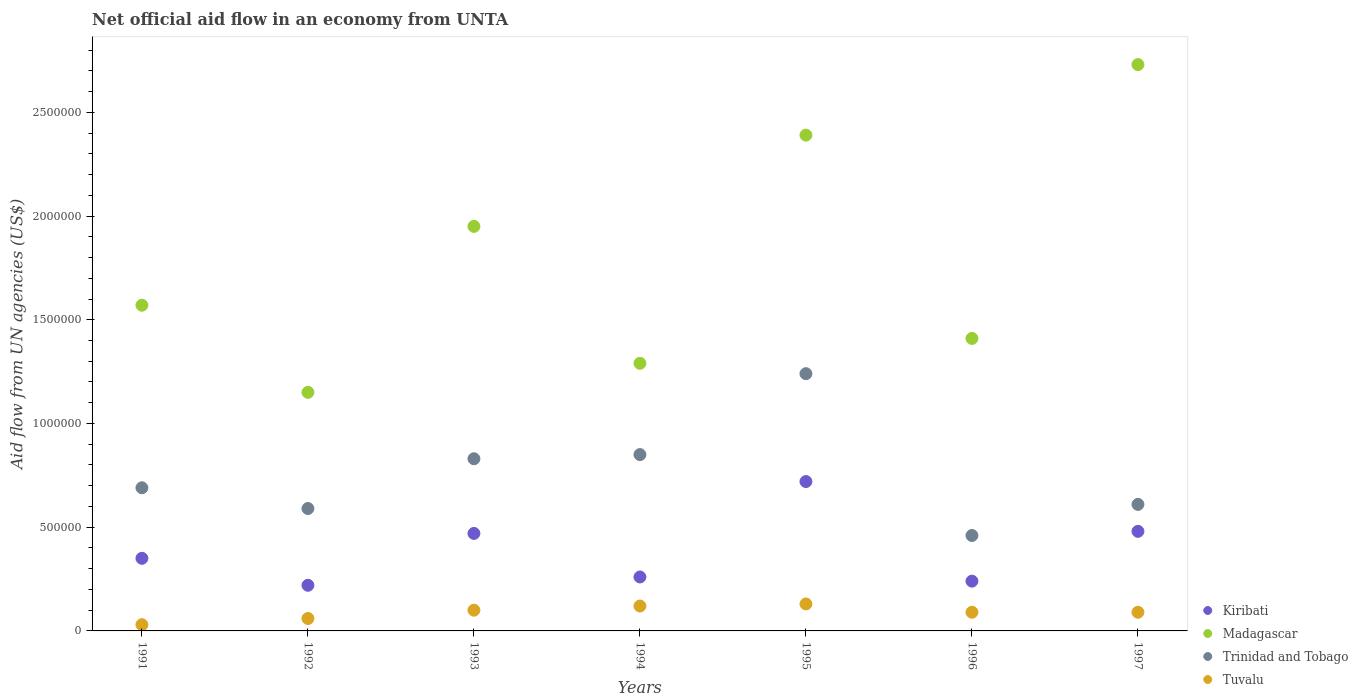What is the net official aid flow in Trinidad and Tobago in 1992?
Provide a succinct answer. 5.90e+05. Across all years, what is the maximum net official aid flow in Tuvalu?
Your answer should be very brief. 1.30e+05. Across all years, what is the minimum net official aid flow in Madagascar?
Give a very brief answer. 1.15e+06. In which year was the net official aid flow in Trinidad and Tobago maximum?
Offer a very short reply. 1995. In which year was the net official aid flow in Madagascar minimum?
Your response must be concise. 1992. What is the total net official aid flow in Tuvalu in the graph?
Give a very brief answer. 6.20e+05. What is the difference between the net official aid flow in Trinidad and Tobago in 1993 and the net official aid flow in Tuvalu in 1996?
Ensure brevity in your answer.  7.40e+05. What is the average net official aid flow in Madagascar per year?
Your response must be concise. 1.78e+06. In the year 1991, what is the difference between the net official aid flow in Kiribati and net official aid flow in Madagascar?
Offer a terse response. -1.22e+06. What is the ratio of the net official aid flow in Madagascar in 1993 to that in 1994?
Your answer should be very brief. 1.51. What is the difference between the highest and the lowest net official aid flow in Trinidad and Tobago?
Your answer should be compact. 7.80e+05. Is it the case that in every year, the sum of the net official aid flow in Trinidad and Tobago and net official aid flow in Tuvalu  is greater than the net official aid flow in Madagascar?
Offer a terse response. No. Does the net official aid flow in Tuvalu monotonically increase over the years?
Your answer should be very brief. No. Is the net official aid flow in Trinidad and Tobago strictly less than the net official aid flow in Kiribati over the years?
Provide a short and direct response. No. How many dotlines are there?
Your answer should be very brief. 4. Are the values on the major ticks of Y-axis written in scientific E-notation?
Provide a short and direct response. No. Does the graph contain any zero values?
Provide a succinct answer. No. Where does the legend appear in the graph?
Make the answer very short. Bottom right. How are the legend labels stacked?
Keep it short and to the point. Vertical. What is the title of the graph?
Make the answer very short. Net official aid flow in an economy from UNTA. What is the label or title of the Y-axis?
Offer a very short reply. Aid flow from UN agencies (US$). What is the Aid flow from UN agencies (US$) in Madagascar in 1991?
Ensure brevity in your answer.  1.57e+06. What is the Aid flow from UN agencies (US$) of Trinidad and Tobago in 1991?
Provide a succinct answer. 6.90e+05. What is the Aid flow from UN agencies (US$) in Madagascar in 1992?
Provide a short and direct response. 1.15e+06. What is the Aid flow from UN agencies (US$) in Trinidad and Tobago in 1992?
Ensure brevity in your answer.  5.90e+05. What is the Aid flow from UN agencies (US$) in Madagascar in 1993?
Keep it short and to the point. 1.95e+06. What is the Aid flow from UN agencies (US$) in Trinidad and Tobago in 1993?
Your response must be concise. 8.30e+05. What is the Aid flow from UN agencies (US$) in Madagascar in 1994?
Your answer should be very brief. 1.29e+06. What is the Aid flow from UN agencies (US$) of Trinidad and Tobago in 1994?
Your answer should be compact. 8.50e+05. What is the Aid flow from UN agencies (US$) in Kiribati in 1995?
Your answer should be compact. 7.20e+05. What is the Aid flow from UN agencies (US$) in Madagascar in 1995?
Offer a very short reply. 2.39e+06. What is the Aid flow from UN agencies (US$) of Trinidad and Tobago in 1995?
Provide a short and direct response. 1.24e+06. What is the Aid flow from UN agencies (US$) of Kiribati in 1996?
Your response must be concise. 2.40e+05. What is the Aid flow from UN agencies (US$) in Madagascar in 1996?
Your answer should be very brief. 1.41e+06. What is the Aid flow from UN agencies (US$) in Kiribati in 1997?
Keep it short and to the point. 4.80e+05. What is the Aid flow from UN agencies (US$) in Madagascar in 1997?
Give a very brief answer. 2.73e+06. What is the Aid flow from UN agencies (US$) in Tuvalu in 1997?
Keep it short and to the point. 9.00e+04. Across all years, what is the maximum Aid flow from UN agencies (US$) in Kiribati?
Provide a short and direct response. 7.20e+05. Across all years, what is the maximum Aid flow from UN agencies (US$) in Madagascar?
Offer a very short reply. 2.73e+06. Across all years, what is the maximum Aid flow from UN agencies (US$) of Trinidad and Tobago?
Make the answer very short. 1.24e+06. Across all years, what is the maximum Aid flow from UN agencies (US$) in Tuvalu?
Your answer should be very brief. 1.30e+05. Across all years, what is the minimum Aid flow from UN agencies (US$) of Madagascar?
Your answer should be very brief. 1.15e+06. What is the total Aid flow from UN agencies (US$) in Kiribati in the graph?
Offer a very short reply. 2.74e+06. What is the total Aid flow from UN agencies (US$) of Madagascar in the graph?
Your answer should be compact. 1.25e+07. What is the total Aid flow from UN agencies (US$) of Trinidad and Tobago in the graph?
Make the answer very short. 5.27e+06. What is the total Aid flow from UN agencies (US$) in Tuvalu in the graph?
Ensure brevity in your answer.  6.20e+05. What is the difference between the Aid flow from UN agencies (US$) of Kiribati in 1991 and that in 1992?
Your answer should be compact. 1.30e+05. What is the difference between the Aid flow from UN agencies (US$) of Trinidad and Tobago in 1991 and that in 1992?
Provide a short and direct response. 1.00e+05. What is the difference between the Aid flow from UN agencies (US$) of Madagascar in 1991 and that in 1993?
Your answer should be very brief. -3.80e+05. What is the difference between the Aid flow from UN agencies (US$) of Trinidad and Tobago in 1991 and that in 1993?
Keep it short and to the point. -1.40e+05. What is the difference between the Aid flow from UN agencies (US$) in Tuvalu in 1991 and that in 1993?
Ensure brevity in your answer.  -7.00e+04. What is the difference between the Aid flow from UN agencies (US$) in Madagascar in 1991 and that in 1994?
Provide a succinct answer. 2.80e+05. What is the difference between the Aid flow from UN agencies (US$) of Trinidad and Tobago in 1991 and that in 1994?
Make the answer very short. -1.60e+05. What is the difference between the Aid flow from UN agencies (US$) in Tuvalu in 1991 and that in 1994?
Offer a very short reply. -9.00e+04. What is the difference between the Aid flow from UN agencies (US$) of Kiribati in 1991 and that in 1995?
Offer a terse response. -3.70e+05. What is the difference between the Aid flow from UN agencies (US$) in Madagascar in 1991 and that in 1995?
Your answer should be compact. -8.20e+05. What is the difference between the Aid flow from UN agencies (US$) in Trinidad and Tobago in 1991 and that in 1995?
Ensure brevity in your answer.  -5.50e+05. What is the difference between the Aid flow from UN agencies (US$) of Madagascar in 1991 and that in 1997?
Your answer should be very brief. -1.16e+06. What is the difference between the Aid flow from UN agencies (US$) in Trinidad and Tobago in 1991 and that in 1997?
Your answer should be very brief. 8.00e+04. What is the difference between the Aid flow from UN agencies (US$) in Kiribati in 1992 and that in 1993?
Provide a short and direct response. -2.50e+05. What is the difference between the Aid flow from UN agencies (US$) in Madagascar in 1992 and that in 1993?
Ensure brevity in your answer.  -8.00e+05. What is the difference between the Aid flow from UN agencies (US$) of Kiribati in 1992 and that in 1994?
Offer a terse response. -4.00e+04. What is the difference between the Aid flow from UN agencies (US$) of Kiribati in 1992 and that in 1995?
Keep it short and to the point. -5.00e+05. What is the difference between the Aid flow from UN agencies (US$) of Madagascar in 1992 and that in 1995?
Offer a terse response. -1.24e+06. What is the difference between the Aid flow from UN agencies (US$) of Trinidad and Tobago in 1992 and that in 1995?
Your response must be concise. -6.50e+05. What is the difference between the Aid flow from UN agencies (US$) in Madagascar in 1992 and that in 1997?
Your answer should be very brief. -1.58e+06. What is the difference between the Aid flow from UN agencies (US$) of Trinidad and Tobago in 1992 and that in 1997?
Provide a succinct answer. -2.00e+04. What is the difference between the Aid flow from UN agencies (US$) of Tuvalu in 1992 and that in 1997?
Provide a succinct answer. -3.00e+04. What is the difference between the Aid flow from UN agencies (US$) in Madagascar in 1993 and that in 1994?
Your response must be concise. 6.60e+05. What is the difference between the Aid flow from UN agencies (US$) in Trinidad and Tobago in 1993 and that in 1994?
Keep it short and to the point. -2.00e+04. What is the difference between the Aid flow from UN agencies (US$) of Kiribati in 1993 and that in 1995?
Provide a short and direct response. -2.50e+05. What is the difference between the Aid flow from UN agencies (US$) in Madagascar in 1993 and that in 1995?
Your answer should be very brief. -4.40e+05. What is the difference between the Aid flow from UN agencies (US$) in Trinidad and Tobago in 1993 and that in 1995?
Offer a terse response. -4.10e+05. What is the difference between the Aid flow from UN agencies (US$) of Tuvalu in 1993 and that in 1995?
Make the answer very short. -3.00e+04. What is the difference between the Aid flow from UN agencies (US$) of Madagascar in 1993 and that in 1996?
Offer a very short reply. 5.40e+05. What is the difference between the Aid flow from UN agencies (US$) of Kiribati in 1993 and that in 1997?
Your response must be concise. -10000. What is the difference between the Aid flow from UN agencies (US$) of Madagascar in 1993 and that in 1997?
Make the answer very short. -7.80e+05. What is the difference between the Aid flow from UN agencies (US$) of Tuvalu in 1993 and that in 1997?
Your answer should be compact. 10000. What is the difference between the Aid flow from UN agencies (US$) in Kiribati in 1994 and that in 1995?
Offer a terse response. -4.60e+05. What is the difference between the Aid flow from UN agencies (US$) in Madagascar in 1994 and that in 1995?
Your answer should be compact. -1.10e+06. What is the difference between the Aid flow from UN agencies (US$) of Trinidad and Tobago in 1994 and that in 1995?
Make the answer very short. -3.90e+05. What is the difference between the Aid flow from UN agencies (US$) of Tuvalu in 1994 and that in 1995?
Make the answer very short. -10000. What is the difference between the Aid flow from UN agencies (US$) in Madagascar in 1994 and that in 1997?
Your answer should be very brief. -1.44e+06. What is the difference between the Aid flow from UN agencies (US$) of Trinidad and Tobago in 1994 and that in 1997?
Your response must be concise. 2.40e+05. What is the difference between the Aid flow from UN agencies (US$) of Madagascar in 1995 and that in 1996?
Your answer should be very brief. 9.80e+05. What is the difference between the Aid flow from UN agencies (US$) of Trinidad and Tobago in 1995 and that in 1996?
Keep it short and to the point. 7.80e+05. What is the difference between the Aid flow from UN agencies (US$) in Madagascar in 1995 and that in 1997?
Provide a short and direct response. -3.40e+05. What is the difference between the Aid flow from UN agencies (US$) in Trinidad and Tobago in 1995 and that in 1997?
Provide a succinct answer. 6.30e+05. What is the difference between the Aid flow from UN agencies (US$) in Tuvalu in 1995 and that in 1997?
Provide a succinct answer. 4.00e+04. What is the difference between the Aid flow from UN agencies (US$) of Kiribati in 1996 and that in 1997?
Ensure brevity in your answer.  -2.40e+05. What is the difference between the Aid flow from UN agencies (US$) of Madagascar in 1996 and that in 1997?
Keep it short and to the point. -1.32e+06. What is the difference between the Aid flow from UN agencies (US$) in Trinidad and Tobago in 1996 and that in 1997?
Offer a terse response. -1.50e+05. What is the difference between the Aid flow from UN agencies (US$) in Kiribati in 1991 and the Aid flow from UN agencies (US$) in Madagascar in 1992?
Make the answer very short. -8.00e+05. What is the difference between the Aid flow from UN agencies (US$) of Kiribati in 1991 and the Aid flow from UN agencies (US$) of Trinidad and Tobago in 1992?
Provide a succinct answer. -2.40e+05. What is the difference between the Aid flow from UN agencies (US$) of Madagascar in 1991 and the Aid flow from UN agencies (US$) of Trinidad and Tobago in 1992?
Keep it short and to the point. 9.80e+05. What is the difference between the Aid flow from UN agencies (US$) of Madagascar in 1991 and the Aid flow from UN agencies (US$) of Tuvalu in 1992?
Make the answer very short. 1.51e+06. What is the difference between the Aid flow from UN agencies (US$) in Trinidad and Tobago in 1991 and the Aid flow from UN agencies (US$) in Tuvalu in 1992?
Provide a succinct answer. 6.30e+05. What is the difference between the Aid flow from UN agencies (US$) of Kiribati in 1991 and the Aid flow from UN agencies (US$) of Madagascar in 1993?
Your answer should be compact. -1.60e+06. What is the difference between the Aid flow from UN agencies (US$) of Kiribati in 1991 and the Aid flow from UN agencies (US$) of Trinidad and Tobago in 1993?
Offer a very short reply. -4.80e+05. What is the difference between the Aid flow from UN agencies (US$) in Madagascar in 1991 and the Aid flow from UN agencies (US$) in Trinidad and Tobago in 1993?
Make the answer very short. 7.40e+05. What is the difference between the Aid flow from UN agencies (US$) in Madagascar in 1991 and the Aid flow from UN agencies (US$) in Tuvalu in 1993?
Your answer should be very brief. 1.47e+06. What is the difference between the Aid flow from UN agencies (US$) of Trinidad and Tobago in 1991 and the Aid flow from UN agencies (US$) of Tuvalu in 1993?
Your answer should be compact. 5.90e+05. What is the difference between the Aid flow from UN agencies (US$) of Kiribati in 1991 and the Aid flow from UN agencies (US$) of Madagascar in 1994?
Make the answer very short. -9.40e+05. What is the difference between the Aid flow from UN agencies (US$) in Kiribati in 1991 and the Aid flow from UN agencies (US$) in Trinidad and Tobago in 1994?
Keep it short and to the point. -5.00e+05. What is the difference between the Aid flow from UN agencies (US$) of Kiribati in 1991 and the Aid flow from UN agencies (US$) of Tuvalu in 1994?
Your answer should be compact. 2.30e+05. What is the difference between the Aid flow from UN agencies (US$) of Madagascar in 1991 and the Aid flow from UN agencies (US$) of Trinidad and Tobago in 1994?
Your answer should be compact. 7.20e+05. What is the difference between the Aid flow from UN agencies (US$) of Madagascar in 1991 and the Aid flow from UN agencies (US$) of Tuvalu in 1994?
Provide a short and direct response. 1.45e+06. What is the difference between the Aid flow from UN agencies (US$) in Trinidad and Tobago in 1991 and the Aid flow from UN agencies (US$) in Tuvalu in 1994?
Provide a succinct answer. 5.70e+05. What is the difference between the Aid flow from UN agencies (US$) in Kiribati in 1991 and the Aid flow from UN agencies (US$) in Madagascar in 1995?
Make the answer very short. -2.04e+06. What is the difference between the Aid flow from UN agencies (US$) of Kiribati in 1991 and the Aid flow from UN agencies (US$) of Trinidad and Tobago in 1995?
Ensure brevity in your answer.  -8.90e+05. What is the difference between the Aid flow from UN agencies (US$) in Kiribati in 1991 and the Aid flow from UN agencies (US$) in Tuvalu in 1995?
Provide a short and direct response. 2.20e+05. What is the difference between the Aid flow from UN agencies (US$) of Madagascar in 1991 and the Aid flow from UN agencies (US$) of Tuvalu in 1995?
Offer a terse response. 1.44e+06. What is the difference between the Aid flow from UN agencies (US$) of Trinidad and Tobago in 1991 and the Aid flow from UN agencies (US$) of Tuvalu in 1995?
Your response must be concise. 5.60e+05. What is the difference between the Aid flow from UN agencies (US$) of Kiribati in 1991 and the Aid flow from UN agencies (US$) of Madagascar in 1996?
Make the answer very short. -1.06e+06. What is the difference between the Aid flow from UN agencies (US$) in Kiribati in 1991 and the Aid flow from UN agencies (US$) in Tuvalu in 1996?
Make the answer very short. 2.60e+05. What is the difference between the Aid flow from UN agencies (US$) of Madagascar in 1991 and the Aid flow from UN agencies (US$) of Trinidad and Tobago in 1996?
Make the answer very short. 1.11e+06. What is the difference between the Aid flow from UN agencies (US$) of Madagascar in 1991 and the Aid flow from UN agencies (US$) of Tuvalu in 1996?
Your response must be concise. 1.48e+06. What is the difference between the Aid flow from UN agencies (US$) in Trinidad and Tobago in 1991 and the Aid flow from UN agencies (US$) in Tuvalu in 1996?
Offer a very short reply. 6.00e+05. What is the difference between the Aid flow from UN agencies (US$) of Kiribati in 1991 and the Aid flow from UN agencies (US$) of Madagascar in 1997?
Provide a succinct answer. -2.38e+06. What is the difference between the Aid flow from UN agencies (US$) in Kiribati in 1991 and the Aid flow from UN agencies (US$) in Tuvalu in 1997?
Provide a succinct answer. 2.60e+05. What is the difference between the Aid flow from UN agencies (US$) in Madagascar in 1991 and the Aid flow from UN agencies (US$) in Trinidad and Tobago in 1997?
Offer a very short reply. 9.60e+05. What is the difference between the Aid flow from UN agencies (US$) in Madagascar in 1991 and the Aid flow from UN agencies (US$) in Tuvalu in 1997?
Make the answer very short. 1.48e+06. What is the difference between the Aid flow from UN agencies (US$) of Kiribati in 1992 and the Aid flow from UN agencies (US$) of Madagascar in 1993?
Ensure brevity in your answer.  -1.73e+06. What is the difference between the Aid flow from UN agencies (US$) in Kiribati in 1992 and the Aid flow from UN agencies (US$) in Trinidad and Tobago in 1993?
Keep it short and to the point. -6.10e+05. What is the difference between the Aid flow from UN agencies (US$) of Kiribati in 1992 and the Aid flow from UN agencies (US$) of Tuvalu in 1993?
Keep it short and to the point. 1.20e+05. What is the difference between the Aid flow from UN agencies (US$) of Madagascar in 1992 and the Aid flow from UN agencies (US$) of Trinidad and Tobago in 1993?
Provide a short and direct response. 3.20e+05. What is the difference between the Aid flow from UN agencies (US$) in Madagascar in 1992 and the Aid flow from UN agencies (US$) in Tuvalu in 1993?
Keep it short and to the point. 1.05e+06. What is the difference between the Aid flow from UN agencies (US$) of Kiribati in 1992 and the Aid flow from UN agencies (US$) of Madagascar in 1994?
Keep it short and to the point. -1.07e+06. What is the difference between the Aid flow from UN agencies (US$) in Kiribati in 1992 and the Aid flow from UN agencies (US$) in Trinidad and Tobago in 1994?
Offer a terse response. -6.30e+05. What is the difference between the Aid flow from UN agencies (US$) in Kiribati in 1992 and the Aid flow from UN agencies (US$) in Tuvalu in 1994?
Offer a very short reply. 1.00e+05. What is the difference between the Aid flow from UN agencies (US$) in Madagascar in 1992 and the Aid flow from UN agencies (US$) in Tuvalu in 1994?
Your response must be concise. 1.03e+06. What is the difference between the Aid flow from UN agencies (US$) in Trinidad and Tobago in 1992 and the Aid flow from UN agencies (US$) in Tuvalu in 1994?
Give a very brief answer. 4.70e+05. What is the difference between the Aid flow from UN agencies (US$) in Kiribati in 1992 and the Aid flow from UN agencies (US$) in Madagascar in 1995?
Ensure brevity in your answer.  -2.17e+06. What is the difference between the Aid flow from UN agencies (US$) of Kiribati in 1992 and the Aid flow from UN agencies (US$) of Trinidad and Tobago in 1995?
Your response must be concise. -1.02e+06. What is the difference between the Aid flow from UN agencies (US$) in Kiribati in 1992 and the Aid flow from UN agencies (US$) in Tuvalu in 1995?
Keep it short and to the point. 9.00e+04. What is the difference between the Aid flow from UN agencies (US$) of Madagascar in 1992 and the Aid flow from UN agencies (US$) of Trinidad and Tobago in 1995?
Your answer should be very brief. -9.00e+04. What is the difference between the Aid flow from UN agencies (US$) of Madagascar in 1992 and the Aid flow from UN agencies (US$) of Tuvalu in 1995?
Your response must be concise. 1.02e+06. What is the difference between the Aid flow from UN agencies (US$) of Trinidad and Tobago in 1992 and the Aid flow from UN agencies (US$) of Tuvalu in 1995?
Ensure brevity in your answer.  4.60e+05. What is the difference between the Aid flow from UN agencies (US$) in Kiribati in 1992 and the Aid flow from UN agencies (US$) in Madagascar in 1996?
Provide a short and direct response. -1.19e+06. What is the difference between the Aid flow from UN agencies (US$) in Kiribati in 1992 and the Aid flow from UN agencies (US$) in Trinidad and Tobago in 1996?
Your answer should be very brief. -2.40e+05. What is the difference between the Aid flow from UN agencies (US$) in Madagascar in 1992 and the Aid flow from UN agencies (US$) in Trinidad and Tobago in 1996?
Your response must be concise. 6.90e+05. What is the difference between the Aid flow from UN agencies (US$) of Madagascar in 1992 and the Aid flow from UN agencies (US$) of Tuvalu in 1996?
Your answer should be very brief. 1.06e+06. What is the difference between the Aid flow from UN agencies (US$) in Kiribati in 1992 and the Aid flow from UN agencies (US$) in Madagascar in 1997?
Offer a very short reply. -2.51e+06. What is the difference between the Aid flow from UN agencies (US$) in Kiribati in 1992 and the Aid flow from UN agencies (US$) in Trinidad and Tobago in 1997?
Provide a short and direct response. -3.90e+05. What is the difference between the Aid flow from UN agencies (US$) in Kiribati in 1992 and the Aid flow from UN agencies (US$) in Tuvalu in 1997?
Your answer should be compact. 1.30e+05. What is the difference between the Aid flow from UN agencies (US$) of Madagascar in 1992 and the Aid flow from UN agencies (US$) of Trinidad and Tobago in 1997?
Offer a very short reply. 5.40e+05. What is the difference between the Aid flow from UN agencies (US$) in Madagascar in 1992 and the Aid flow from UN agencies (US$) in Tuvalu in 1997?
Provide a short and direct response. 1.06e+06. What is the difference between the Aid flow from UN agencies (US$) in Trinidad and Tobago in 1992 and the Aid flow from UN agencies (US$) in Tuvalu in 1997?
Your response must be concise. 5.00e+05. What is the difference between the Aid flow from UN agencies (US$) of Kiribati in 1993 and the Aid flow from UN agencies (US$) of Madagascar in 1994?
Your response must be concise. -8.20e+05. What is the difference between the Aid flow from UN agencies (US$) in Kiribati in 1993 and the Aid flow from UN agencies (US$) in Trinidad and Tobago in 1994?
Ensure brevity in your answer.  -3.80e+05. What is the difference between the Aid flow from UN agencies (US$) of Kiribati in 1993 and the Aid flow from UN agencies (US$) of Tuvalu in 1994?
Give a very brief answer. 3.50e+05. What is the difference between the Aid flow from UN agencies (US$) in Madagascar in 1993 and the Aid flow from UN agencies (US$) in Trinidad and Tobago in 1994?
Provide a short and direct response. 1.10e+06. What is the difference between the Aid flow from UN agencies (US$) of Madagascar in 1993 and the Aid flow from UN agencies (US$) of Tuvalu in 1994?
Keep it short and to the point. 1.83e+06. What is the difference between the Aid flow from UN agencies (US$) in Trinidad and Tobago in 1993 and the Aid flow from UN agencies (US$) in Tuvalu in 1994?
Your answer should be very brief. 7.10e+05. What is the difference between the Aid flow from UN agencies (US$) in Kiribati in 1993 and the Aid flow from UN agencies (US$) in Madagascar in 1995?
Offer a very short reply. -1.92e+06. What is the difference between the Aid flow from UN agencies (US$) of Kiribati in 1993 and the Aid flow from UN agencies (US$) of Trinidad and Tobago in 1995?
Your answer should be compact. -7.70e+05. What is the difference between the Aid flow from UN agencies (US$) of Madagascar in 1993 and the Aid flow from UN agencies (US$) of Trinidad and Tobago in 1995?
Give a very brief answer. 7.10e+05. What is the difference between the Aid flow from UN agencies (US$) of Madagascar in 1993 and the Aid flow from UN agencies (US$) of Tuvalu in 1995?
Ensure brevity in your answer.  1.82e+06. What is the difference between the Aid flow from UN agencies (US$) in Kiribati in 1993 and the Aid flow from UN agencies (US$) in Madagascar in 1996?
Ensure brevity in your answer.  -9.40e+05. What is the difference between the Aid flow from UN agencies (US$) of Kiribati in 1993 and the Aid flow from UN agencies (US$) of Tuvalu in 1996?
Offer a very short reply. 3.80e+05. What is the difference between the Aid flow from UN agencies (US$) in Madagascar in 1993 and the Aid flow from UN agencies (US$) in Trinidad and Tobago in 1996?
Your answer should be compact. 1.49e+06. What is the difference between the Aid flow from UN agencies (US$) in Madagascar in 1993 and the Aid flow from UN agencies (US$) in Tuvalu in 1996?
Give a very brief answer. 1.86e+06. What is the difference between the Aid flow from UN agencies (US$) in Trinidad and Tobago in 1993 and the Aid flow from UN agencies (US$) in Tuvalu in 1996?
Provide a succinct answer. 7.40e+05. What is the difference between the Aid flow from UN agencies (US$) of Kiribati in 1993 and the Aid flow from UN agencies (US$) of Madagascar in 1997?
Give a very brief answer. -2.26e+06. What is the difference between the Aid flow from UN agencies (US$) in Madagascar in 1993 and the Aid flow from UN agencies (US$) in Trinidad and Tobago in 1997?
Make the answer very short. 1.34e+06. What is the difference between the Aid flow from UN agencies (US$) in Madagascar in 1993 and the Aid flow from UN agencies (US$) in Tuvalu in 1997?
Keep it short and to the point. 1.86e+06. What is the difference between the Aid flow from UN agencies (US$) of Trinidad and Tobago in 1993 and the Aid flow from UN agencies (US$) of Tuvalu in 1997?
Keep it short and to the point. 7.40e+05. What is the difference between the Aid flow from UN agencies (US$) of Kiribati in 1994 and the Aid flow from UN agencies (US$) of Madagascar in 1995?
Offer a terse response. -2.13e+06. What is the difference between the Aid flow from UN agencies (US$) of Kiribati in 1994 and the Aid flow from UN agencies (US$) of Trinidad and Tobago in 1995?
Provide a short and direct response. -9.80e+05. What is the difference between the Aid flow from UN agencies (US$) in Madagascar in 1994 and the Aid flow from UN agencies (US$) in Trinidad and Tobago in 1995?
Offer a very short reply. 5.00e+04. What is the difference between the Aid flow from UN agencies (US$) in Madagascar in 1994 and the Aid flow from UN agencies (US$) in Tuvalu in 1995?
Keep it short and to the point. 1.16e+06. What is the difference between the Aid flow from UN agencies (US$) of Trinidad and Tobago in 1994 and the Aid flow from UN agencies (US$) of Tuvalu in 1995?
Make the answer very short. 7.20e+05. What is the difference between the Aid flow from UN agencies (US$) of Kiribati in 1994 and the Aid flow from UN agencies (US$) of Madagascar in 1996?
Give a very brief answer. -1.15e+06. What is the difference between the Aid flow from UN agencies (US$) of Kiribati in 1994 and the Aid flow from UN agencies (US$) of Trinidad and Tobago in 1996?
Offer a terse response. -2.00e+05. What is the difference between the Aid flow from UN agencies (US$) of Madagascar in 1994 and the Aid flow from UN agencies (US$) of Trinidad and Tobago in 1996?
Offer a terse response. 8.30e+05. What is the difference between the Aid flow from UN agencies (US$) of Madagascar in 1994 and the Aid flow from UN agencies (US$) of Tuvalu in 1996?
Make the answer very short. 1.20e+06. What is the difference between the Aid flow from UN agencies (US$) in Trinidad and Tobago in 1994 and the Aid flow from UN agencies (US$) in Tuvalu in 1996?
Provide a succinct answer. 7.60e+05. What is the difference between the Aid flow from UN agencies (US$) in Kiribati in 1994 and the Aid flow from UN agencies (US$) in Madagascar in 1997?
Keep it short and to the point. -2.47e+06. What is the difference between the Aid flow from UN agencies (US$) in Kiribati in 1994 and the Aid flow from UN agencies (US$) in Trinidad and Tobago in 1997?
Keep it short and to the point. -3.50e+05. What is the difference between the Aid flow from UN agencies (US$) in Kiribati in 1994 and the Aid flow from UN agencies (US$) in Tuvalu in 1997?
Your response must be concise. 1.70e+05. What is the difference between the Aid flow from UN agencies (US$) of Madagascar in 1994 and the Aid flow from UN agencies (US$) of Trinidad and Tobago in 1997?
Your response must be concise. 6.80e+05. What is the difference between the Aid flow from UN agencies (US$) of Madagascar in 1994 and the Aid flow from UN agencies (US$) of Tuvalu in 1997?
Your answer should be very brief. 1.20e+06. What is the difference between the Aid flow from UN agencies (US$) in Trinidad and Tobago in 1994 and the Aid flow from UN agencies (US$) in Tuvalu in 1997?
Your answer should be compact. 7.60e+05. What is the difference between the Aid flow from UN agencies (US$) in Kiribati in 1995 and the Aid flow from UN agencies (US$) in Madagascar in 1996?
Provide a short and direct response. -6.90e+05. What is the difference between the Aid flow from UN agencies (US$) in Kiribati in 1995 and the Aid flow from UN agencies (US$) in Tuvalu in 1996?
Provide a short and direct response. 6.30e+05. What is the difference between the Aid flow from UN agencies (US$) of Madagascar in 1995 and the Aid flow from UN agencies (US$) of Trinidad and Tobago in 1996?
Offer a very short reply. 1.93e+06. What is the difference between the Aid flow from UN agencies (US$) of Madagascar in 1995 and the Aid flow from UN agencies (US$) of Tuvalu in 1996?
Give a very brief answer. 2.30e+06. What is the difference between the Aid flow from UN agencies (US$) in Trinidad and Tobago in 1995 and the Aid flow from UN agencies (US$) in Tuvalu in 1996?
Provide a succinct answer. 1.15e+06. What is the difference between the Aid flow from UN agencies (US$) in Kiribati in 1995 and the Aid flow from UN agencies (US$) in Madagascar in 1997?
Your answer should be compact. -2.01e+06. What is the difference between the Aid flow from UN agencies (US$) in Kiribati in 1995 and the Aid flow from UN agencies (US$) in Trinidad and Tobago in 1997?
Provide a short and direct response. 1.10e+05. What is the difference between the Aid flow from UN agencies (US$) of Kiribati in 1995 and the Aid flow from UN agencies (US$) of Tuvalu in 1997?
Offer a very short reply. 6.30e+05. What is the difference between the Aid flow from UN agencies (US$) in Madagascar in 1995 and the Aid flow from UN agencies (US$) in Trinidad and Tobago in 1997?
Offer a terse response. 1.78e+06. What is the difference between the Aid flow from UN agencies (US$) of Madagascar in 1995 and the Aid flow from UN agencies (US$) of Tuvalu in 1997?
Provide a succinct answer. 2.30e+06. What is the difference between the Aid flow from UN agencies (US$) of Trinidad and Tobago in 1995 and the Aid flow from UN agencies (US$) of Tuvalu in 1997?
Offer a very short reply. 1.15e+06. What is the difference between the Aid flow from UN agencies (US$) in Kiribati in 1996 and the Aid flow from UN agencies (US$) in Madagascar in 1997?
Your answer should be compact. -2.49e+06. What is the difference between the Aid flow from UN agencies (US$) of Kiribati in 1996 and the Aid flow from UN agencies (US$) of Trinidad and Tobago in 1997?
Provide a succinct answer. -3.70e+05. What is the difference between the Aid flow from UN agencies (US$) in Kiribati in 1996 and the Aid flow from UN agencies (US$) in Tuvalu in 1997?
Your response must be concise. 1.50e+05. What is the difference between the Aid flow from UN agencies (US$) of Madagascar in 1996 and the Aid flow from UN agencies (US$) of Tuvalu in 1997?
Ensure brevity in your answer.  1.32e+06. What is the difference between the Aid flow from UN agencies (US$) of Trinidad and Tobago in 1996 and the Aid flow from UN agencies (US$) of Tuvalu in 1997?
Provide a succinct answer. 3.70e+05. What is the average Aid flow from UN agencies (US$) in Kiribati per year?
Offer a terse response. 3.91e+05. What is the average Aid flow from UN agencies (US$) of Madagascar per year?
Ensure brevity in your answer.  1.78e+06. What is the average Aid flow from UN agencies (US$) in Trinidad and Tobago per year?
Make the answer very short. 7.53e+05. What is the average Aid flow from UN agencies (US$) of Tuvalu per year?
Provide a short and direct response. 8.86e+04. In the year 1991, what is the difference between the Aid flow from UN agencies (US$) in Kiribati and Aid flow from UN agencies (US$) in Madagascar?
Your answer should be very brief. -1.22e+06. In the year 1991, what is the difference between the Aid flow from UN agencies (US$) of Kiribati and Aid flow from UN agencies (US$) of Trinidad and Tobago?
Provide a short and direct response. -3.40e+05. In the year 1991, what is the difference between the Aid flow from UN agencies (US$) in Kiribati and Aid flow from UN agencies (US$) in Tuvalu?
Make the answer very short. 3.20e+05. In the year 1991, what is the difference between the Aid flow from UN agencies (US$) in Madagascar and Aid flow from UN agencies (US$) in Trinidad and Tobago?
Offer a terse response. 8.80e+05. In the year 1991, what is the difference between the Aid flow from UN agencies (US$) of Madagascar and Aid flow from UN agencies (US$) of Tuvalu?
Provide a succinct answer. 1.54e+06. In the year 1992, what is the difference between the Aid flow from UN agencies (US$) of Kiribati and Aid flow from UN agencies (US$) of Madagascar?
Offer a terse response. -9.30e+05. In the year 1992, what is the difference between the Aid flow from UN agencies (US$) in Kiribati and Aid flow from UN agencies (US$) in Trinidad and Tobago?
Offer a terse response. -3.70e+05. In the year 1992, what is the difference between the Aid flow from UN agencies (US$) in Kiribati and Aid flow from UN agencies (US$) in Tuvalu?
Your answer should be very brief. 1.60e+05. In the year 1992, what is the difference between the Aid flow from UN agencies (US$) in Madagascar and Aid flow from UN agencies (US$) in Trinidad and Tobago?
Your answer should be very brief. 5.60e+05. In the year 1992, what is the difference between the Aid flow from UN agencies (US$) of Madagascar and Aid flow from UN agencies (US$) of Tuvalu?
Your answer should be compact. 1.09e+06. In the year 1992, what is the difference between the Aid flow from UN agencies (US$) in Trinidad and Tobago and Aid flow from UN agencies (US$) in Tuvalu?
Ensure brevity in your answer.  5.30e+05. In the year 1993, what is the difference between the Aid flow from UN agencies (US$) of Kiribati and Aid flow from UN agencies (US$) of Madagascar?
Your answer should be compact. -1.48e+06. In the year 1993, what is the difference between the Aid flow from UN agencies (US$) in Kiribati and Aid flow from UN agencies (US$) in Trinidad and Tobago?
Keep it short and to the point. -3.60e+05. In the year 1993, what is the difference between the Aid flow from UN agencies (US$) in Madagascar and Aid flow from UN agencies (US$) in Trinidad and Tobago?
Offer a very short reply. 1.12e+06. In the year 1993, what is the difference between the Aid flow from UN agencies (US$) of Madagascar and Aid flow from UN agencies (US$) of Tuvalu?
Give a very brief answer. 1.85e+06. In the year 1993, what is the difference between the Aid flow from UN agencies (US$) in Trinidad and Tobago and Aid flow from UN agencies (US$) in Tuvalu?
Provide a short and direct response. 7.30e+05. In the year 1994, what is the difference between the Aid flow from UN agencies (US$) in Kiribati and Aid flow from UN agencies (US$) in Madagascar?
Provide a succinct answer. -1.03e+06. In the year 1994, what is the difference between the Aid flow from UN agencies (US$) of Kiribati and Aid flow from UN agencies (US$) of Trinidad and Tobago?
Provide a succinct answer. -5.90e+05. In the year 1994, what is the difference between the Aid flow from UN agencies (US$) of Kiribati and Aid flow from UN agencies (US$) of Tuvalu?
Your answer should be compact. 1.40e+05. In the year 1994, what is the difference between the Aid flow from UN agencies (US$) of Madagascar and Aid flow from UN agencies (US$) of Tuvalu?
Provide a succinct answer. 1.17e+06. In the year 1994, what is the difference between the Aid flow from UN agencies (US$) in Trinidad and Tobago and Aid flow from UN agencies (US$) in Tuvalu?
Give a very brief answer. 7.30e+05. In the year 1995, what is the difference between the Aid flow from UN agencies (US$) of Kiribati and Aid flow from UN agencies (US$) of Madagascar?
Your response must be concise. -1.67e+06. In the year 1995, what is the difference between the Aid flow from UN agencies (US$) of Kiribati and Aid flow from UN agencies (US$) of Trinidad and Tobago?
Your answer should be very brief. -5.20e+05. In the year 1995, what is the difference between the Aid flow from UN agencies (US$) of Kiribati and Aid flow from UN agencies (US$) of Tuvalu?
Give a very brief answer. 5.90e+05. In the year 1995, what is the difference between the Aid flow from UN agencies (US$) in Madagascar and Aid flow from UN agencies (US$) in Trinidad and Tobago?
Offer a terse response. 1.15e+06. In the year 1995, what is the difference between the Aid flow from UN agencies (US$) of Madagascar and Aid flow from UN agencies (US$) of Tuvalu?
Your answer should be compact. 2.26e+06. In the year 1995, what is the difference between the Aid flow from UN agencies (US$) of Trinidad and Tobago and Aid flow from UN agencies (US$) of Tuvalu?
Ensure brevity in your answer.  1.11e+06. In the year 1996, what is the difference between the Aid flow from UN agencies (US$) of Kiribati and Aid flow from UN agencies (US$) of Madagascar?
Offer a very short reply. -1.17e+06. In the year 1996, what is the difference between the Aid flow from UN agencies (US$) of Madagascar and Aid flow from UN agencies (US$) of Trinidad and Tobago?
Provide a succinct answer. 9.50e+05. In the year 1996, what is the difference between the Aid flow from UN agencies (US$) in Madagascar and Aid flow from UN agencies (US$) in Tuvalu?
Provide a succinct answer. 1.32e+06. In the year 1996, what is the difference between the Aid flow from UN agencies (US$) in Trinidad and Tobago and Aid flow from UN agencies (US$) in Tuvalu?
Give a very brief answer. 3.70e+05. In the year 1997, what is the difference between the Aid flow from UN agencies (US$) in Kiribati and Aid flow from UN agencies (US$) in Madagascar?
Offer a very short reply. -2.25e+06. In the year 1997, what is the difference between the Aid flow from UN agencies (US$) in Kiribati and Aid flow from UN agencies (US$) in Trinidad and Tobago?
Offer a very short reply. -1.30e+05. In the year 1997, what is the difference between the Aid flow from UN agencies (US$) of Kiribati and Aid flow from UN agencies (US$) of Tuvalu?
Provide a succinct answer. 3.90e+05. In the year 1997, what is the difference between the Aid flow from UN agencies (US$) of Madagascar and Aid flow from UN agencies (US$) of Trinidad and Tobago?
Your response must be concise. 2.12e+06. In the year 1997, what is the difference between the Aid flow from UN agencies (US$) of Madagascar and Aid flow from UN agencies (US$) of Tuvalu?
Make the answer very short. 2.64e+06. In the year 1997, what is the difference between the Aid flow from UN agencies (US$) in Trinidad and Tobago and Aid flow from UN agencies (US$) in Tuvalu?
Your answer should be compact. 5.20e+05. What is the ratio of the Aid flow from UN agencies (US$) of Kiribati in 1991 to that in 1992?
Your answer should be very brief. 1.59. What is the ratio of the Aid flow from UN agencies (US$) of Madagascar in 1991 to that in 1992?
Make the answer very short. 1.37. What is the ratio of the Aid flow from UN agencies (US$) of Trinidad and Tobago in 1991 to that in 1992?
Make the answer very short. 1.17. What is the ratio of the Aid flow from UN agencies (US$) in Tuvalu in 1991 to that in 1992?
Provide a short and direct response. 0.5. What is the ratio of the Aid flow from UN agencies (US$) of Kiribati in 1991 to that in 1993?
Your answer should be compact. 0.74. What is the ratio of the Aid flow from UN agencies (US$) of Madagascar in 1991 to that in 1993?
Provide a short and direct response. 0.81. What is the ratio of the Aid flow from UN agencies (US$) of Trinidad and Tobago in 1991 to that in 1993?
Your answer should be compact. 0.83. What is the ratio of the Aid flow from UN agencies (US$) of Tuvalu in 1991 to that in 1993?
Make the answer very short. 0.3. What is the ratio of the Aid flow from UN agencies (US$) of Kiribati in 1991 to that in 1994?
Your response must be concise. 1.35. What is the ratio of the Aid flow from UN agencies (US$) in Madagascar in 1991 to that in 1994?
Provide a succinct answer. 1.22. What is the ratio of the Aid flow from UN agencies (US$) in Trinidad and Tobago in 1991 to that in 1994?
Your response must be concise. 0.81. What is the ratio of the Aid flow from UN agencies (US$) of Kiribati in 1991 to that in 1995?
Your answer should be very brief. 0.49. What is the ratio of the Aid flow from UN agencies (US$) of Madagascar in 1991 to that in 1995?
Your response must be concise. 0.66. What is the ratio of the Aid flow from UN agencies (US$) of Trinidad and Tobago in 1991 to that in 1995?
Your response must be concise. 0.56. What is the ratio of the Aid flow from UN agencies (US$) in Tuvalu in 1991 to that in 1995?
Your response must be concise. 0.23. What is the ratio of the Aid flow from UN agencies (US$) in Kiribati in 1991 to that in 1996?
Offer a very short reply. 1.46. What is the ratio of the Aid flow from UN agencies (US$) of Madagascar in 1991 to that in 1996?
Your response must be concise. 1.11. What is the ratio of the Aid flow from UN agencies (US$) in Trinidad and Tobago in 1991 to that in 1996?
Provide a short and direct response. 1.5. What is the ratio of the Aid flow from UN agencies (US$) in Tuvalu in 1991 to that in 1996?
Your answer should be very brief. 0.33. What is the ratio of the Aid flow from UN agencies (US$) in Kiribati in 1991 to that in 1997?
Give a very brief answer. 0.73. What is the ratio of the Aid flow from UN agencies (US$) in Madagascar in 1991 to that in 1997?
Make the answer very short. 0.58. What is the ratio of the Aid flow from UN agencies (US$) in Trinidad and Tobago in 1991 to that in 1997?
Offer a terse response. 1.13. What is the ratio of the Aid flow from UN agencies (US$) of Kiribati in 1992 to that in 1993?
Make the answer very short. 0.47. What is the ratio of the Aid flow from UN agencies (US$) of Madagascar in 1992 to that in 1993?
Keep it short and to the point. 0.59. What is the ratio of the Aid flow from UN agencies (US$) of Trinidad and Tobago in 1992 to that in 1993?
Your answer should be very brief. 0.71. What is the ratio of the Aid flow from UN agencies (US$) in Tuvalu in 1992 to that in 1993?
Provide a succinct answer. 0.6. What is the ratio of the Aid flow from UN agencies (US$) in Kiribati in 1992 to that in 1994?
Provide a succinct answer. 0.85. What is the ratio of the Aid flow from UN agencies (US$) of Madagascar in 1992 to that in 1994?
Your answer should be very brief. 0.89. What is the ratio of the Aid flow from UN agencies (US$) of Trinidad and Tobago in 1992 to that in 1994?
Your answer should be very brief. 0.69. What is the ratio of the Aid flow from UN agencies (US$) of Tuvalu in 1992 to that in 1994?
Make the answer very short. 0.5. What is the ratio of the Aid flow from UN agencies (US$) of Kiribati in 1992 to that in 1995?
Keep it short and to the point. 0.31. What is the ratio of the Aid flow from UN agencies (US$) in Madagascar in 1992 to that in 1995?
Give a very brief answer. 0.48. What is the ratio of the Aid flow from UN agencies (US$) of Trinidad and Tobago in 1992 to that in 1995?
Your answer should be very brief. 0.48. What is the ratio of the Aid flow from UN agencies (US$) in Tuvalu in 1992 to that in 1995?
Your answer should be very brief. 0.46. What is the ratio of the Aid flow from UN agencies (US$) in Kiribati in 1992 to that in 1996?
Offer a terse response. 0.92. What is the ratio of the Aid flow from UN agencies (US$) in Madagascar in 1992 to that in 1996?
Offer a terse response. 0.82. What is the ratio of the Aid flow from UN agencies (US$) in Trinidad and Tobago in 1992 to that in 1996?
Offer a terse response. 1.28. What is the ratio of the Aid flow from UN agencies (US$) of Tuvalu in 1992 to that in 1996?
Provide a succinct answer. 0.67. What is the ratio of the Aid flow from UN agencies (US$) of Kiribati in 1992 to that in 1997?
Keep it short and to the point. 0.46. What is the ratio of the Aid flow from UN agencies (US$) of Madagascar in 1992 to that in 1997?
Make the answer very short. 0.42. What is the ratio of the Aid flow from UN agencies (US$) of Trinidad and Tobago in 1992 to that in 1997?
Make the answer very short. 0.97. What is the ratio of the Aid flow from UN agencies (US$) of Kiribati in 1993 to that in 1994?
Ensure brevity in your answer.  1.81. What is the ratio of the Aid flow from UN agencies (US$) in Madagascar in 1993 to that in 1994?
Provide a succinct answer. 1.51. What is the ratio of the Aid flow from UN agencies (US$) in Trinidad and Tobago in 1993 to that in 1994?
Your answer should be compact. 0.98. What is the ratio of the Aid flow from UN agencies (US$) in Kiribati in 1993 to that in 1995?
Your answer should be compact. 0.65. What is the ratio of the Aid flow from UN agencies (US$) in Madagascar in 1993 to that in 1995?
Your answer should be very brief. 0.82. What is the ratio of the Aid flow from UN agencies (US$) in Trinidad and Tobago in 1993 to that in 1995?
Provide a short and direct response. 0.67. What is the ratio of the Aid flow from UN agencies (US$) of Tuvalu in 1993 to that in 1995?
Ensure brevity in your answer.  0.77. What is the ratio of the Aid flow from UN agencies (US$) in Kiribati in 1993 to that in 1996?
Your answer should be very brief. 1.96. What is the ratio of the Aid flow from UN agencies (US$) of Madagascar in 1993 to that in 1996?
Give a very brief answer. 1.38. What is the ratio of the Aid flow from UN agencies (US$) of Trinidad and Tobago in 1993 to that in 1996?
Give a very brief answer. 1.8. What is the ratio of the Aid flow from UN agencies (US$) in Tuvalu in 1993 to that in 1996?
Make the answer very short. 1.11. What is the ratio of the Aid flow from UN agencies (US$) in Kiribati in 1993 to that in 1997?
Your answer should be very brief. 0.98. What is the ratio of the Aid flow from UN agencies (US$) in Trinidad and Tobago in 1993 to that in 1997?
Ensure brevity in your answer.  1.36. What is the ratio of the Aid flow from UN agencies (US$) in Tuvalu in 1993 to that in 1997?
Make the answer very short. 1.11. What is the ratio of the Aid flow from UN agencies (US$) of Kiribati in 1994 to that in 1995?
Provide a succinct answer. 0.36. What is the ratio of the Aid flow from UN agencies (US$) in Madagascar in 1994 to that in 1995?
Your answer should be compact. 0.54. What is the ratio of the Aid flow from UN agencies (US$) in Trinidad and Tobago in 1994 to that in 1995?
Offer a very short reply. 0.69. What is the ratio of the Aid flow from UN agencies (US$) of Madagascar in 1994 to that in 1996?
Your answer should be very brief. 0.91. What is the ratio of the Aid flow from UN agencies (US$) in Trinidad and Tobago in 1994 to that in 1996?
Make the answer very short. 1.85. What is the ratio of the Aid flow from UN agencies (US$) of Kiribati in 1994 to that in 1997?
Keep it short and to the point. 0.54. What is the ratio of the Aid flow from UN agencies (US$) in Madagascar in 1994 to that in 1997?
Offer a terse response. 0.47. What is the ratio of the Aid flow from UN agencies (US$) in Trinidad and Tobago in 1994 to that in 1997?
Ensure brevity in your answer.  1.39. What is the ratio of the Aid flow from UN agencies (US$) of Tuvalu in 1994 to that in 1997?
Your answer should be compact. 1.33. What is the ratio of the Aid flow from UN agencies (US$) in Madagascar in 1995 to that in 1996?
Offer a terse response. 1.7. What is the ratio of the Aid flow from UN agencies (US$) of Trinidad and Tobago in 1995 to that in 1996?
Give a very brief answer. 2.7. What is the ratio of the Aid flow from UN agencies (US$) of Tuvalu in 1995 to that in 1996?
Give a very brief answer. 1.44. What is the ratio of the Aid flow from UN agencies (US$) of Madagascar in 1995 to that in 1997?
Your answer should be very brief. 0.88. What is the ratio of the Aid flow from UN agencies (US$) in Trinidad and Tobago in 1995 to that in 1997?
Give a very brief answer. 2.03. What is the ratio of the Aid flow from UN agencies (US$) in Tuvalu in 1995 to that in 1997?
Offer a terse response. 1.44. What is the ratio of the Aid flow from UN agencies (US$) of Kiribati in 1996 to that in 1997?
Give a very brief answer. 0.5. What is the ratio of the Aid flow from UN agencies (US$) in Madagascar in 1996 to that in 1997?
Your answer should be compact. 0.52. What is the ratio of the Aid flow from UN agencies (US$) in Trinidad and Tobago in 1996 to that in 1997?
Your answer should be very brief. 0.75. What is the ratio of the Aid flow from UN agencies (US$) in Tuvalu in 1996 to that in 1997?
Give a very brief answer. 1. What is the difference between the highest and the second highest Aid flow from UN agencies (US$) of Madagascar?
Give a very brief answer. 3.40e+05. What is the difference between the highest and the lowest Aid flow from UN agencies (US$) of Madagascar?
Your answer should be very brief. 1.58e+06. What is the difference between the highest and the lowest Aid flow from UN agencies (US$) in Trinidad and Tobago?
Offer a very short reply. 7.80e+05. What is the difference between the highest and the lowest Aid flow from UN agencies (US$) of Tuvalu?
Your answer should be very brief. 1.00e+05. 